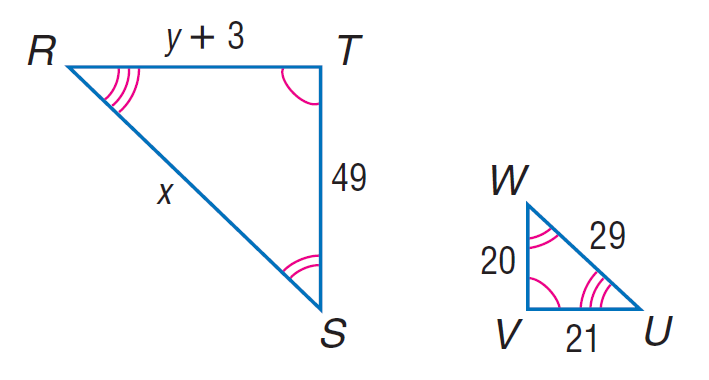Answer the mathemtical geometry problem and directly provide the correct option letter.
Question: Each pair of polygons is similar. Find y.
Choices: A: 48.45 B: 49 C: 88 D: 110 A 